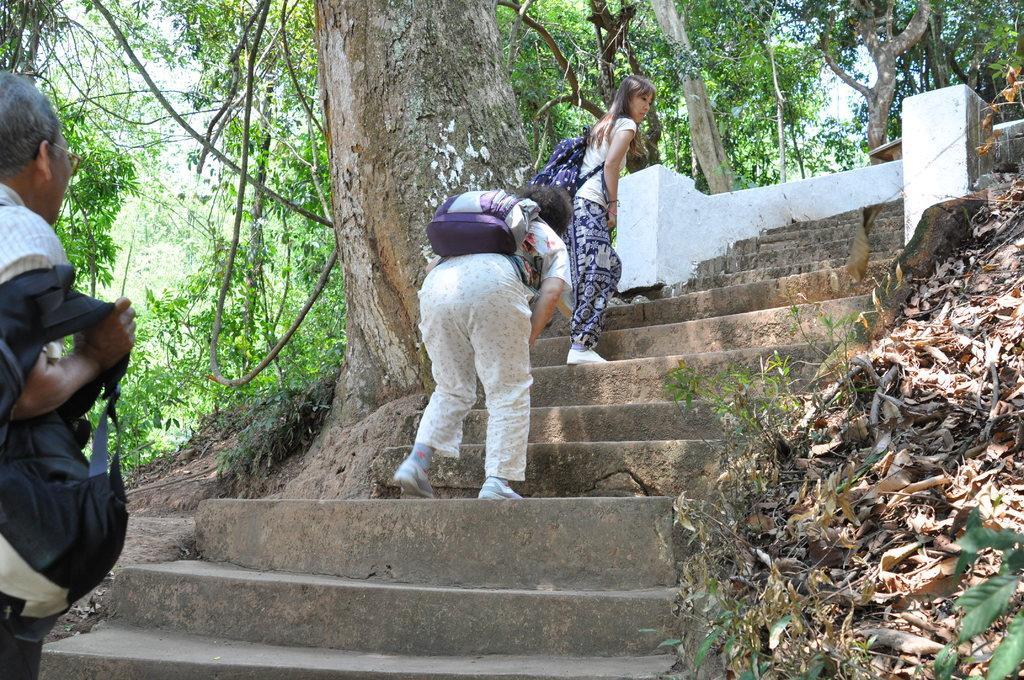Please provide a concise description of this image. In this image I can see a woman wearing white shirt, blue pant and white shoe is standing and wearing a blue colored bag and another person wearing white pant is standing and wearing a bag, few stairs, few trees and the sky. To the right side of the image I can see few leaves and to the left side of the image I can see another person holding a black colored bag in his hand. 